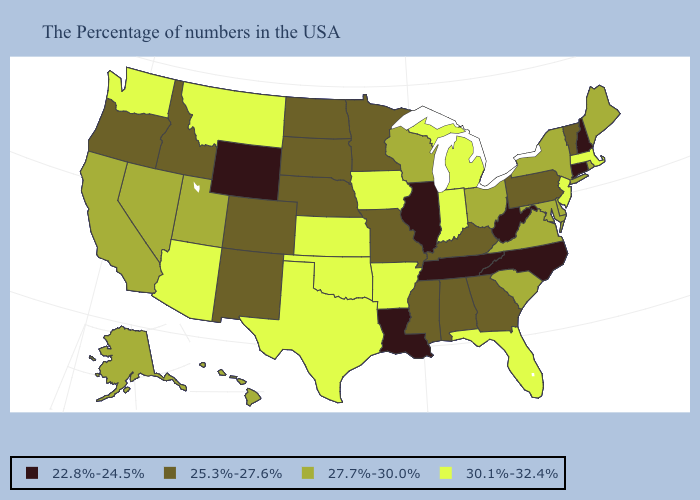What is the value of Ohio?
Keep it brief. 27.7%-30.0%. Which states have the lowest value in the South?
Short answer required. North Carolina, West Virginia, Tennessee, Louisiana. Does Washington have the highest value in the USA?
Keep it brief. Yes. Name the states that have a value in the range 27.7%-30.0%?
Write a very short answer. Maine, Rhode Island, New York, Delaware, Maryland, Virginia, South Carolina, Ohio, Wisconsin, Utah, Nevada, California, Alaska, Hawaii. Does Iowa have the same value as Missouri?
Be succinct. No. What is the lowest value in the USA?
Answer briefly. 22.8%-24.5%. Name the states that have a value in the range 25.3%-27.6%?
Short answer required. Vermont, Pennsylvania, Georgia, Kentucky, Alabama, Mississippi, Missouri, Minnesota, Nebraska, South Dakota, North Dakota, Colorado, New Mexico, Idaho, Oregon. What is the value of Alabama?
Quick response, please. 25.3%-27.6%. Name the states that have a value in the range 25.3%-27.6%?
Give a very brief answer. Vermont, Pennsylvania, Georgia, Kentucky, Alabama, Mississippi, Missouri, Minnesota, Nebraska, South Dakota, North Dakota, Colorado, New Mexico, Idaho, Oregon. What is the value of Virginia?
Give a very brief answer. 27.7%-30.0%. Does Illinois have a lower value than California?
Answer briefly. Yes. What is the value of New Hampshire?
Answer briefly. 22.8%-24.5%. Among the states that border Missouri , which have the lowest value?
Write a very short answer. Tennessee, Illinois. What is the lowest value in the South?
Short answer required. 22.8%-24.5%. What is the lowest value in the USA?
Short answer required. 22.8%-24.5%. 